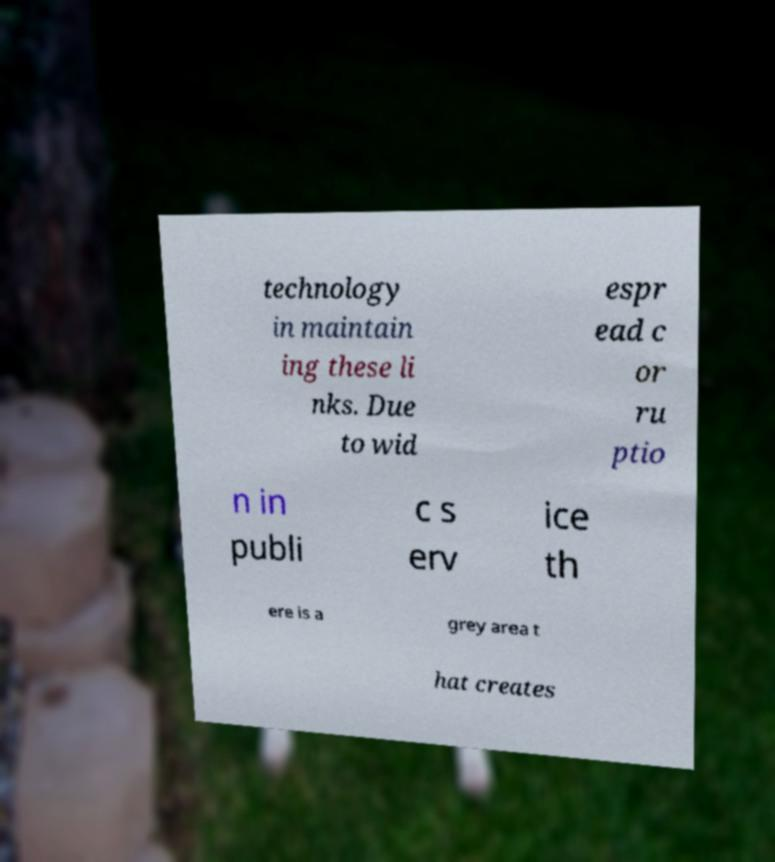Could you assist in decoding the text presented in this image and type it out clearly? technology in maintain ing these li nks. Due to wid espr ead c or ru ptio n in publi c s erv ice th ere is a grey area t hat creates 